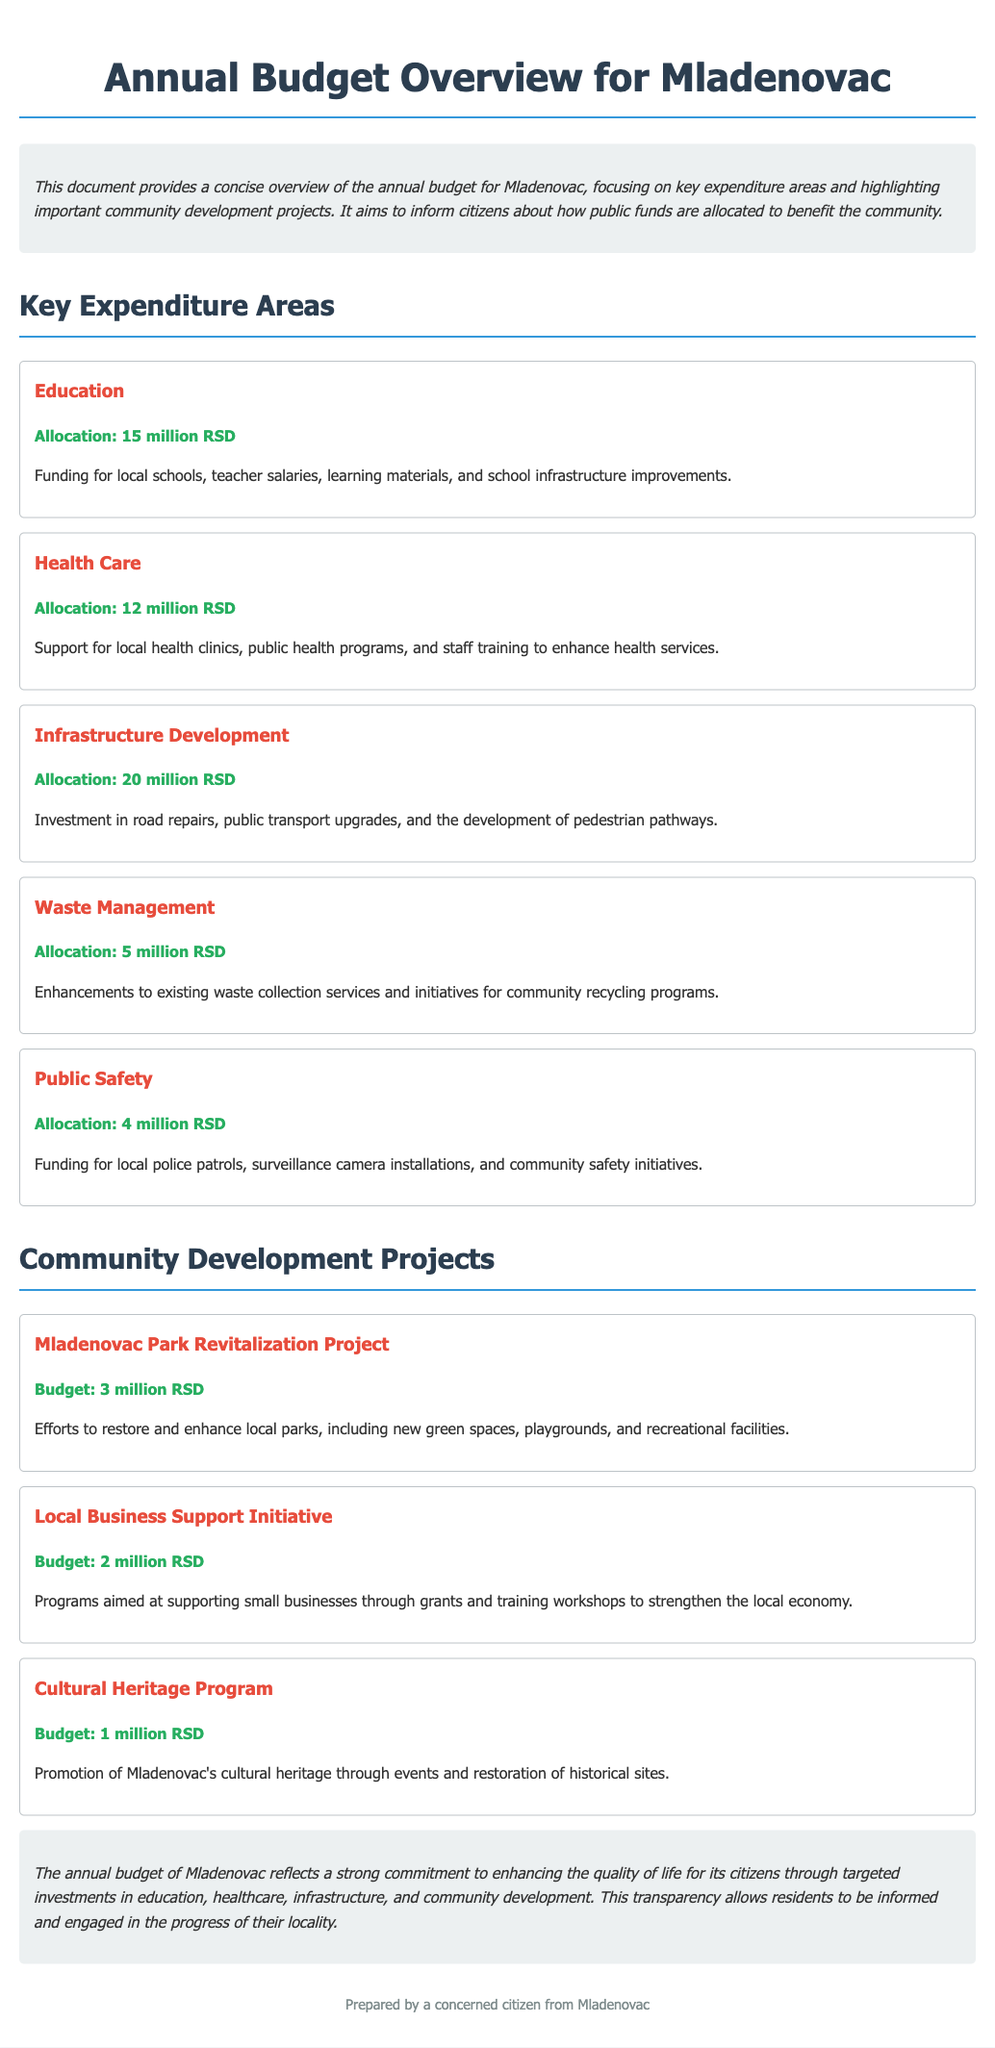What is the total allocation for Education? The total allocation for Education is explicitly mentioned in the document as 15 million RSD.
Answer: 15 million RSD What is the budget for the Mladenovac Park Revitalization Project? The budget for this specific community development project is stated as 3 million RSD in the document.
Answer: 3 million RSD How much money is allocated to Public Safety? The allocation for Public Safety is detailed in the document as 4 million RSD.
Answer: 4 million RSD Which expenditure area has the highest allocation? By comparing the allocations, Infrastructure Development has the highest allocation of 20 million RSD.
Answer: Infrastructure Development What is the total number of key expenditure areas listed? The document lists a total of five key expenditure areas under the relevant section.
Answer: 5 What is the budget for the Cultural Heritage Program? The budget for the Cultural Heritage Program, as indicated in the document, is 1 million RSD.
Answer: 1 million RSD What supports local health clinics according to the document? The document specifies that 12 million RSD is allocated to support local health clinics and public health programs.
Answer: Health Care What community initiative aims to support small businesses? The Local Business Support Initiative is aimed at supporting small businesses through grants and training.
Answer: Local Business Support Initiative What is the overarching goal of Mladenovac's annual budget? The document indicates that the overarching goal is to enhance the quality of life for its citizens.
Answer: Enhance quality of life 